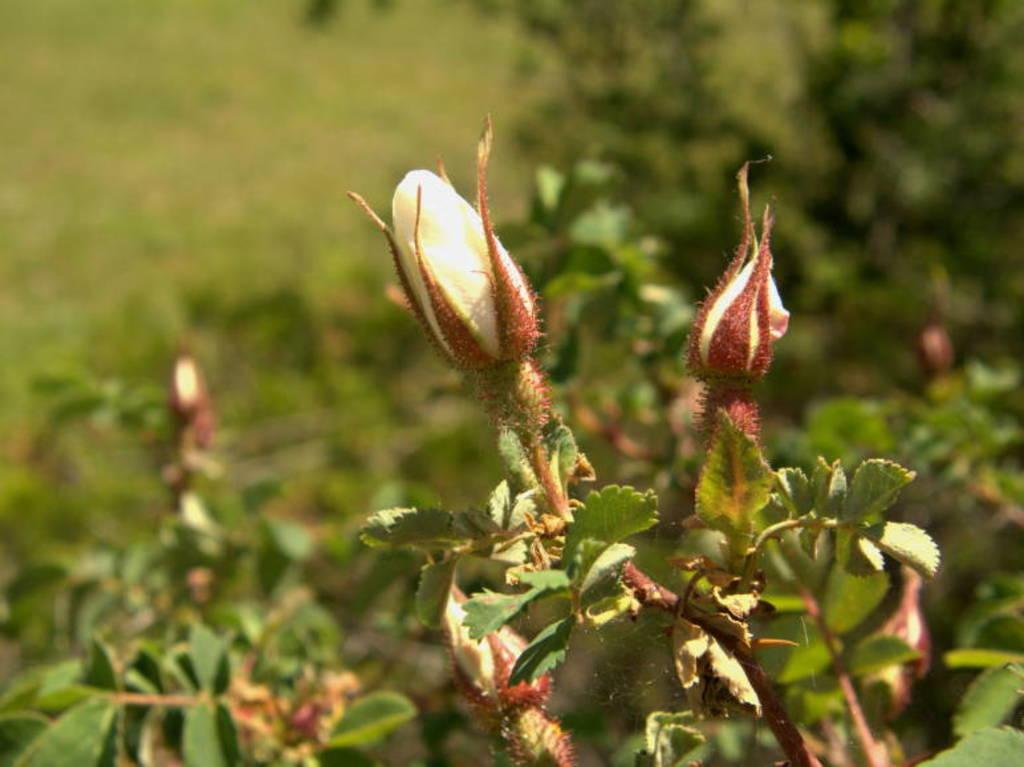What type of living organisms can be seen in the image? The image contains plants. What specific part of the plants can be seen in the foreground? There are buds in the foreground of the image. How would you describe the background of the image? The background of the image is blurred. What can be observed in the background besides the blurred effect? There is greenery in the background of the image. How many boxes can be seen in the image? There are no boxes present in the image. What type of impulse can be observed in the boys' actions in the image? There are no boys present in the image, and therefore no impulses can be observed. 